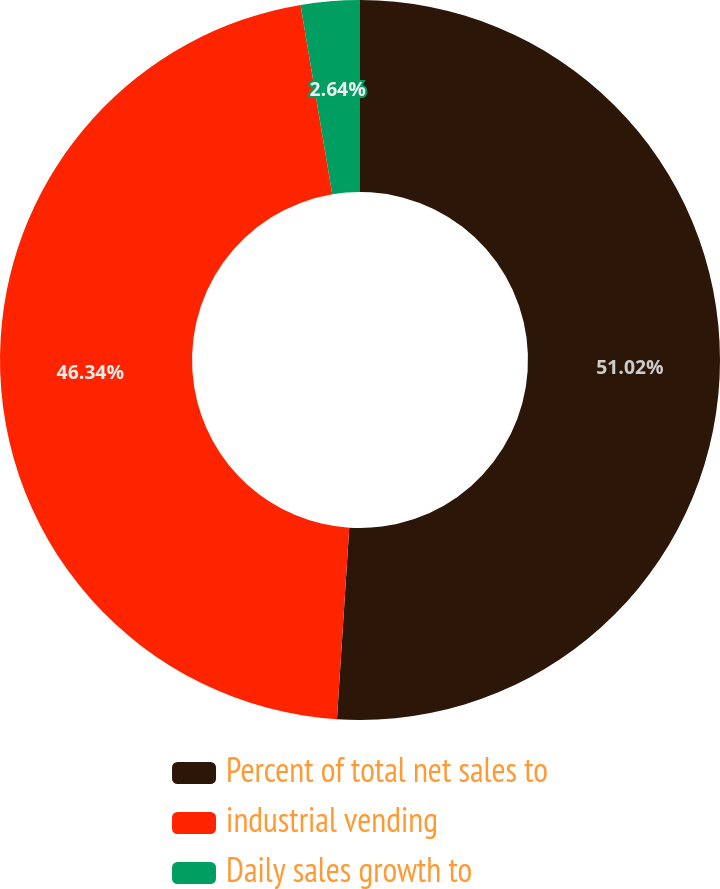<chart> <loc_0><loc_0><loc_500><loc_500><pie_chart><fcel>Percent of total net sales to<fcel>industrial vending<fcel>Daily sales growth to<nl><fcel>51.02%<fcel>46.34%<fcel>2.64%<nl></chart> 